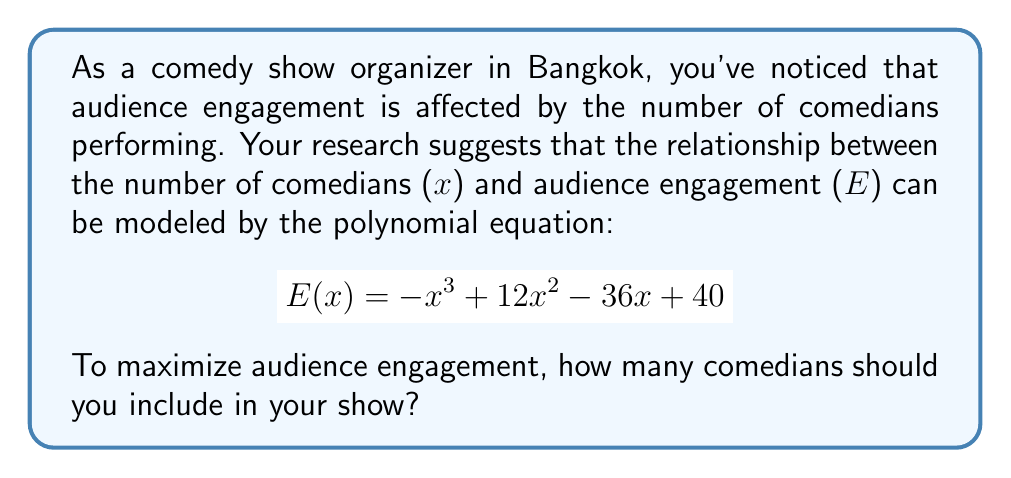Teach me how to tackle this problem. To find the optimal number of comedians for maximum audience engagement, we need to find the maximum point of the given polynomial function. This can be done by following these steps:

1) First, we need to find the derivative of $E(x)$:
   $$ E'(x) = -3x^2 + 24x - 36 $$

2) To find the critical points, set $E'(x) = 0$:
   $$ -3x^2 + 24x - 36 = 0 $$

3) This is a quadratic equation. We can solve it using the quadratic formula:
   $$ x = \frac{-b \pm \sqrt{b^2 - 4ac}}{2a} $$
   where $a = -3$, $b = 24$, and $c = -36$

4) Plugging in these values:
   $$ x = \frac{-24 \pm \sqrt{24^2 - 4(-3)(-36)}}{2(-3)} $$
   $$ = \frac{-24 \pm \sqrt{576 - 432}}{-6} $$
   $$ = \frac{-24 \pm \sqrt{144}}{-6} $$
   $$ = \frac{-24 \pm 12}{-6} $$

5) This gives us two solutions:
   $$ x_1 = \frac{-24 + 12}{-6} = 2 $$
   $$ x_2 = \frac{-24 - 12}{-6} = 6 $$

6) To determine which of these gives the maximum, we can check the second derivative:
   $$ E''(x) = -6x + 24 $$
   
   At $x = 2$: $E''(2) = -12 + 24 = 12 > 0$, so this is a local minimum.
   At $x = 6$: $E''(6) = -36 + 24 = -12 < 0$, so this is a local maximum.

Therefore, the maximum audience engagement occurs when there are 6 comedians.
Answer: The optimal number of comedians for maximum audience engagement is 6. 